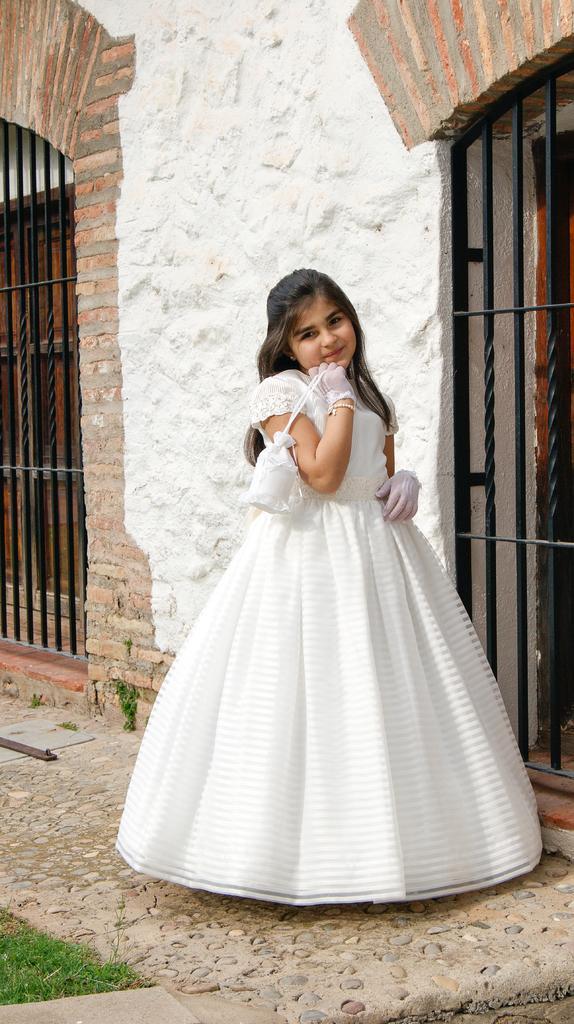Describe this image in one or two sentences. In this image we can see a girl is standing and holding a small bag in her hand. In the background we can see gates, wall, doors and at the bottom we can see grass on the ground. 